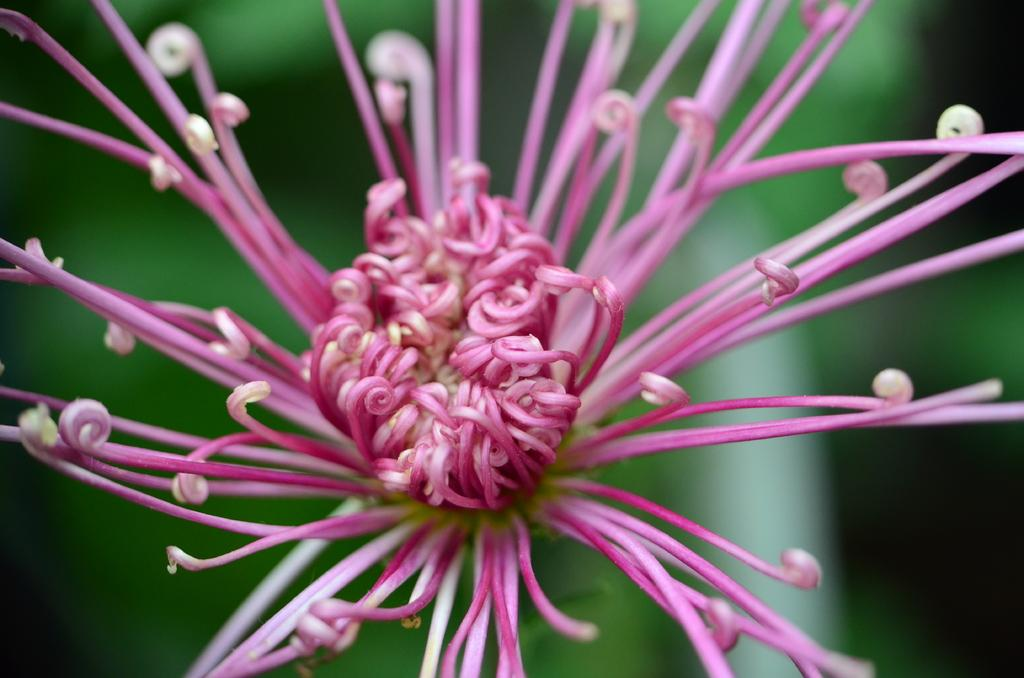What is the main subject of the image? There is a flower in the image. Can you describe the background of the image? The background of the image is blurry. How many passengers are visible in the image? There are no passengers present in the image, as it features a flower and a blurry background. 